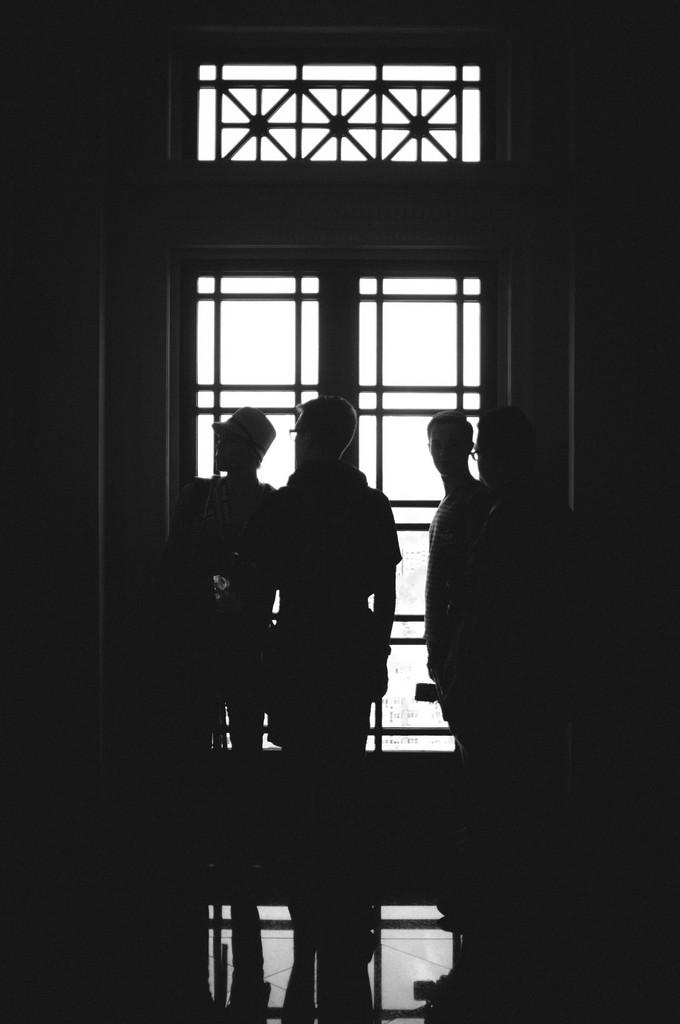What can be inferred about the lighting conditions in the image? The image was taken in a dark environment. How many people are present in the image? There are three persons standing in the image. What architectural feature can be seen in the background of the image? There is a window visible on a wall in the background of the image. What type of test is being conducted in the image? There is no indication of a test being conducted in the image. What role does the sponge play in the image? There is no sponge present in the image. 